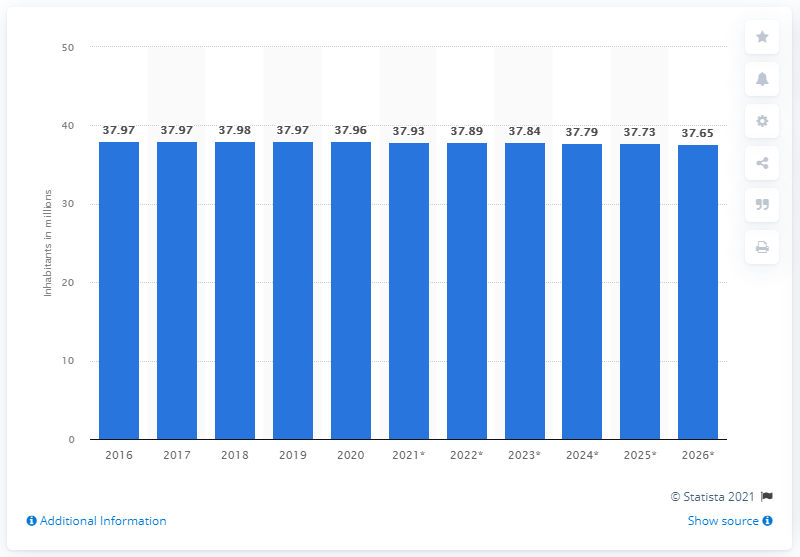List a handful of essential elements in this visual. In 2020, the population of Poland was 37.65 million. In the year 2020, the population of Poland reached 38 million. 